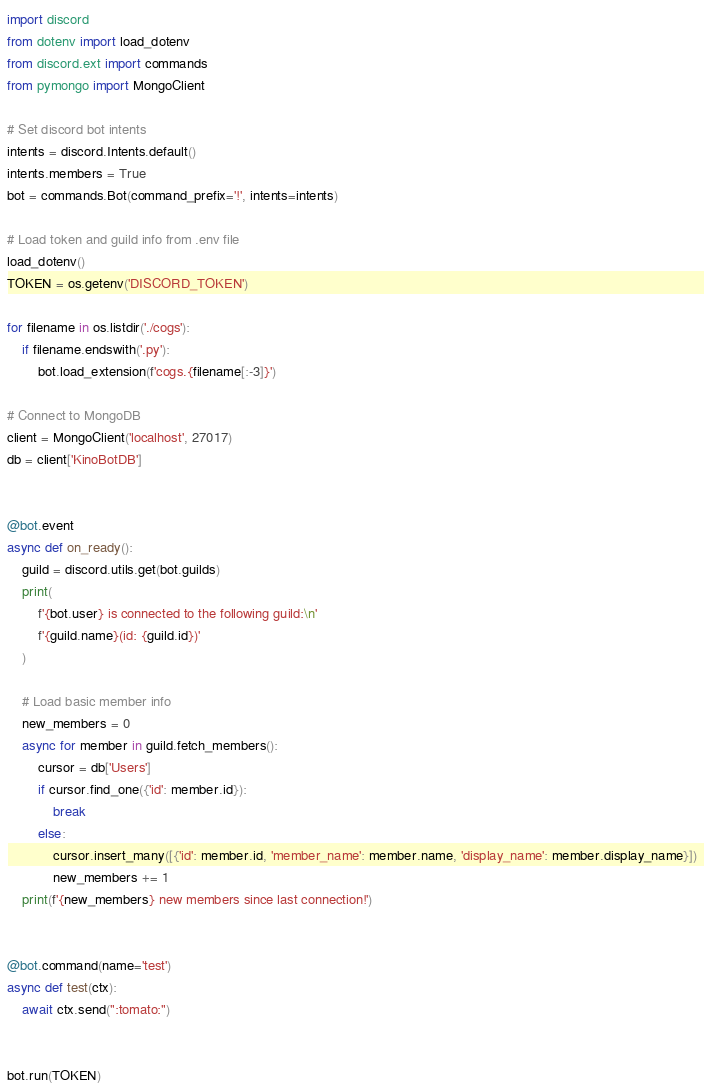<code> <loc_0><loc_0><loc_500><loc_500><_Python_>import discord
from dotenv import load_dotenv
from discord.ext import commands
from pymongo import MongoClient

# Set discord bot intents
intents = discord.Intents.default()
intents.members = True
bot = commands.Bot(command_prefix='!', intents=intents)

# Load token and guild info from .env file
load_dotenv()
TOKEN = os.getenv('DISCORD_TOKEN')

for filename in os.listdir('./cogs'):
    if filename.endswith('.py'):
        bot.load_extension(f'cogs.{filename[:-3]}')

# Connect to MongoDB
client = MongoClient('localhost', 27017)
db = client['KinoBotDB']


@bot.event
async def on_ready():
    guild = discord.utils.get(bot.guilds)
    print(
        f'{bot.user} is connected to the following guild:\n'
        f'{guild.name}(id: {guild.id})'
    )

    # Load basic member info
    new_members = 0
    async for member in guild.fetch_members():
        cursor = db['Users']
        if cursor.find_one({'id': member.id}):
            break
        else:
            cursor.insert_many([{'id': member.id, 'member_name': member.name, 'display_name': member.display_name}])
            new_members += 1
    print(f'{new_members} new members since last connection!')


@bot.command(name='test')
async def test(ctx):
    await ctx.send(":tomato:")


bot.run(TOKEN)
</code> 